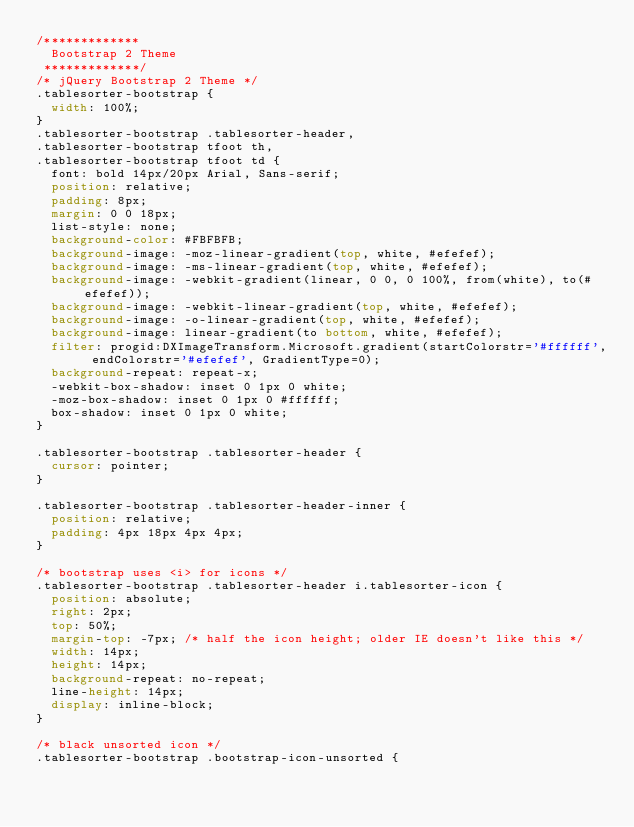<code> <loc_0><loc_0><loc_500><loc_500><_CSS_>/*************
  Bootstrap 2 Theme
 *************/
/* jQuery Bootstrap 2 Theme */
.tablesorter-bootstrap {
	width: 100%;
}
.tablesorter-bootstrap .tablesorter-header,
.tablesorter-bootstrap tfoot th,
.tablesorter-bootstrap tfoot td {
	font: bold 14px/20px Arial, Sans-serif;
	position: relative;
	padding: 8px;
	margin: 0 0 18px;
	list-style: none;
	background-color: #FBFBFB;
	background-image: -moz-linear-gradient(top, white, #efefef);
	background-image: -ms-linear-gradient(top, white, #efefef);
	background-image: -webkit-gradient(linear, 0 0, 0 100%, from(white), to(#efefef));
	background-image: -webkit-linear-gradient(top, white, #efefef);
	background-image: -o-linear-gradient(top, white, #efefef);
	background-image: linear-gradient(to bottom, white, #efefef);
	filter: progid:DXImageTransform.Microsoft.gradient(startColorstr='#ffffff', endColorstr='#efefef', GradientType=0);
	background-repeat: repeat-x;
	-webkit-box-shadow: inset 0 1px 0 white;
	-moz-box-shadow: inset 0 1px 0 #ffffff;
	box-shadow: inset 0 1px 0 white;
}

.tablesorter-bootstrap .tablesorter-header {
	cursor: pointer;
}

.tablesorter-bootstrap .tablesorter-header-inner {
	position: relative;
	padding: 4px 18px 4px 4px;
}

/* bootstrap uses <i> for icons */
.tablesorter-bootstrap .tablesorter-header i.tablesorter-icon {
	position: absolute;
	right: 2px;
	top: 50%;
	margin-top: -7px; /* half the icon height; older IE doesn't like this */
	width: 14px;
	height: 14px;
	background-repeat: no-repeat;
	line-height: 14px;
	display: inline-block;
}

/* black unsorted icon */
.tablesorter-bootstrap .bootstrap-icon-unsorted {</code> 